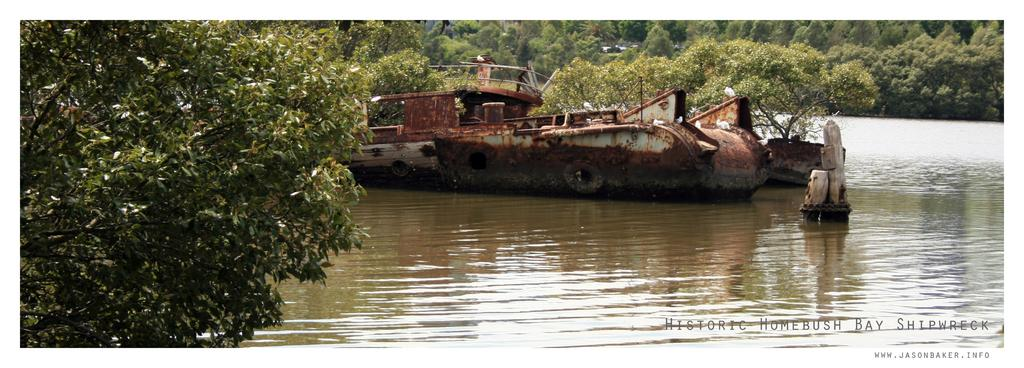What type of boat is in the image? There is an old rusted boat in the image. Where is the boat located? The boat is on a river. What can be seen in the background of the image? Trees are visible in the image. What is the primary element in the image? There is water visible in the image. What type of cracker is floating on the water in the image? There is no cracker present in the image; it only features an old rusted boat on a river. What time of day is it in the image? The provided facts do not give any information about the time of day, so it cannot be determined from the image. 